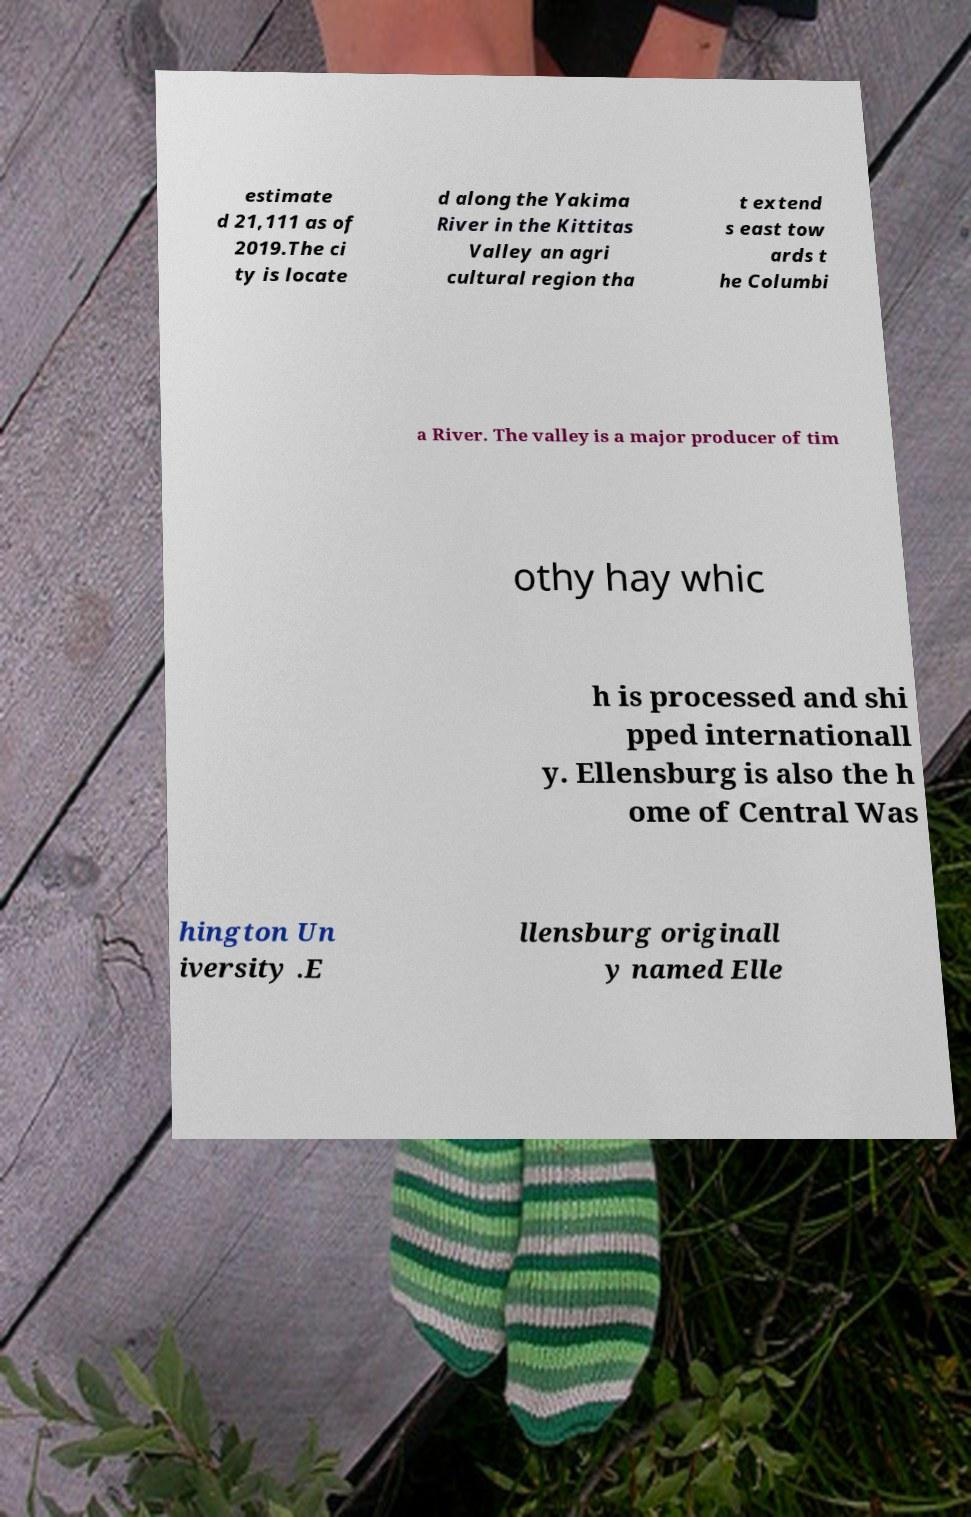Can you read and provide the text displayed in the image?This photo seems to have some interesting text. Can you extract and type it out for me? estimate d 21,111 as of 2019.The ci ty is locate d along the Yakima River in the Kittitas Valley an agri cultural region tha t extend s east tow ards t he Columbi a River. The valley is a major producer of tim othy hay whic h is processed and shi pped internationall y. Ellensburg is also the h ome of Central Was hington Un iversity .E llensburg originall y named Elle 